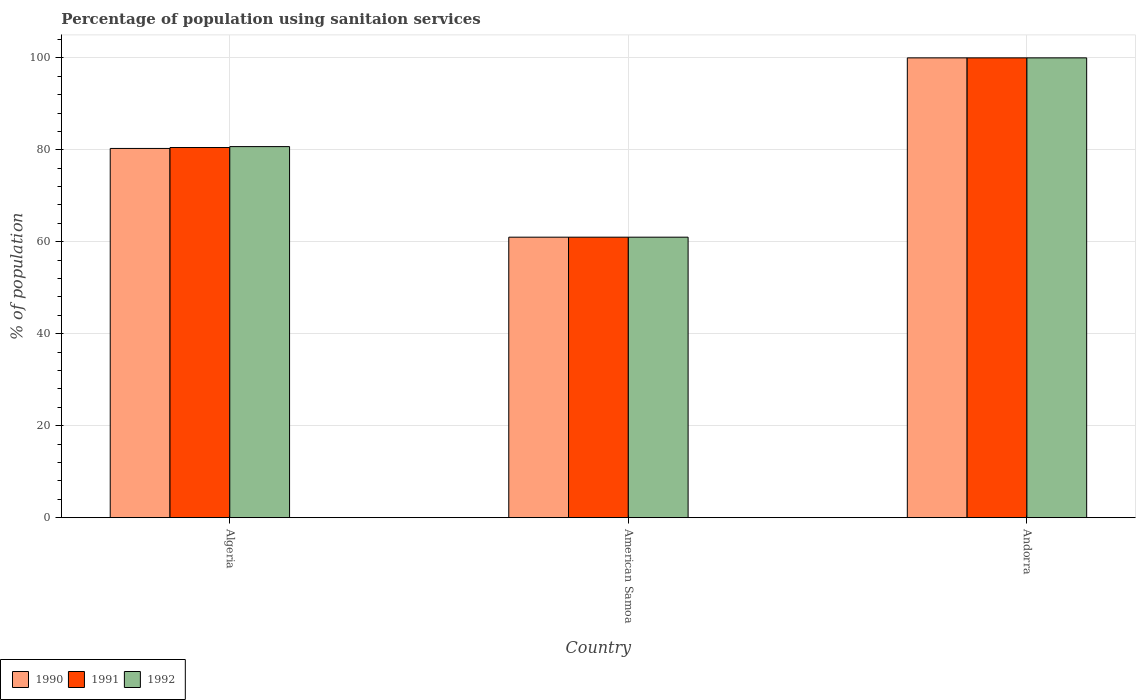How many different coloured bars are there?
Ensure brevity in your answer.  3. How many groups of bars are there?
Offer a terse response. 3. Are the number of bars per tick equal to the number of legend labels?
Offer a terse response. Yes. Are the number of bars on each tick of the X-axis equal?
Offer a terse response. Yes. What is the label of the 1st group of bars from the left?
Make the answer very short. Algeria. In how many cases, is the number of bars for a given country not equal to the number of legend labels?
Offer a very short reply. 0. What is the percentage of population using sanitaion services in 1991 in American Samoa?
Your answer should be very brief. 61. Across all countries, what is the maximum percentage of population using sanitaion services in 1991?
Offer a very short reply. 100. Across all countries, what is the minimum percentage of population using sanitaion services in 1991?
Your answer should be compact. 61. In which country was the percentage of population using sanitaion services in 1991 maximum?
Offer a terse response. Andorra. In which country was the percentage of population using sanitaion services in 1991 minimum?
Ensure brevity in your answer.  American Samoa. What is the total percentage of population using sanitaion services in 1990 in the graph?
Offer a terse response. 241.3. What is the difference between the percentage of population using sanitaion services in 1991 in American Samoa and that in Andorra?
Keep it short and to the point. -39. What is the difference between the percentage of population using sanitaion services in 1990 in American Samoa and the percentage of population using sanitaion services in 1991 in Andorra?
Give a very brief answer. -39. What is the average percentage of population using sanitaion services in 1991 per country?
Make the answer very short. 80.5. What is the ratio of the percentage of population using sanitaion services in 1991 in Algeria to that in Andorra?
Your answer should be compact. 0.81. What is the difference between the highest and the second highest percentage of population using sanitaion services in 1992?
Your answer should be compact. -19.3. Is the sum of the percentage of population using sanitaion services in 1991 in Algeria and American Samoa greater than the maximum percentage of population using sanitaion services in 1990 across all countries?
Give a very brief answer. Yes. Is it the case that in every country, the sum of the percentage of population using sanitaion services in 1990 and percentage of population using sanitaion services in 1992 is greater than the percentage of population using sanitaion services in 1991?
Your response must be concise. Yes. How many bars are there?
Provide a succinct answer. 9. How many countries are there in the graph?
Offer a terse response. 3. What is the difference between two consecutive major ticks on the Y-axis?
Give a very brief answer. 20. How are the legend labels stacked?
Keep it short and to the point. Horizontal. What is the title of the graph?
Make the answer very short. Percentage of population using sanitaion services. Does "1976" appear as one of the legend labels in the graph?
Keep it short and to the point. No. What is the label or title of the X-axis?
Ensure brevity in your answer.  Country. What is the label or title of the Y-axis?
Offer a very short reply. % of population. What is the % of population in 1990 in Algeria?
Your response must be concise. 80.3. What is the % of population of 1991 in Algeria?
Keep it short and to the point. 80.5. What is the % of population in 1992 in Algeria?
Your answer should be compact. 80.7. What is the % of population of 1991 in American Samoa?
Your answer should be very brief. 61. What is the % of population of 1991 in Andorra?
Give a very brief answer. 100. What is the % of population of 1992 in Andorra?
Your answer should be very brief. 100. Across all countries, what is the maximum % of population in 1992?
Offer a terse response. 100. Across all countries, what is the minimum % of population of 1991?
Provide a short and direct response. 61. Across all countries, what is the minimum % of population in 1992?
Your response must be concise. 61. What is the total % of population of 1990 in the graph?
Make the answer very short. 241.3. What is the total % of population of 1991 in the graph?
Offer a terse response. 241.5. What is the total % of population in 1992 in the graph?
Your answer should be compact. 241.7. What is the difference between the % of population of 1990 in Algeria and that in American Samoa?
Your answer should be compact. 19.3. What is the difference between the % of population of 1992 in Algeria and that in American Samoa?
Provide a short and direct response. 19.7. What is the difference between the % of population in 1990 in Algeria and that in Andorra?
Your answer should be compact. -19.7. What is the difference between the % of population in 1991 in Algeria and that in Andorra?
Ensure brevity in your answer.  -19.5. What is the difference between the % of population of 1992 in Algeria and that in Andorra?
Your answer should be compact. -19.3. What is the difference between the % of population of 1990 in American Samoa and that in Andorra?
Provide a succinct answer. -39. What is the difference between the % of population of 1991 in American Samoa and that in Andorra?
Keep it short and to the point. -39. What is the difference between the % of population in 1992 in American Samoa and that in Andorra?
Provide a succinct answer. -39. What is the difference between the % of population in 1990 in Algeria and the % of population in 1991 in American Samoa?
Offer a very short reply. 19.3. What is the difference between the % of population in 1990 in Algeria and the % of population in 1992 in American Samoa?
Your response must be concise. 19.3. What is the difference between the % of population of 1991 in Algeria and the % of population of 1992 in American Samoa?
Your answer should be compact. 19.5. What is the difference between the % of population in 1990 in Algeria and the % of population in 1991 in Andorra?
Your response must be concise. -19.7. What is the difference between the % of population of 1990 in Algeria and the % of population of 1992 in Andorra?
Make the answer very short. -19.7. What is the difference between the % of population of 1991 in Algeria and the % of population of 1992 in Andorra?
Your answer should be compact. -19.5. What is the difference between the % of population in 1990 in American Samoa and the % of population in 1991 in Andorra?
Keep it short and to the point. -39. What is the difference between the % of population in 1990 in American Samoa and the % of population in 1992 in Andorra?
Provide a short and direct response. -39. What is the difference between the % of population of 1991 in American Samoa and the % of population of 1992 in Andorra?
Make the answer very short. -39. What is the average % of population in 1990 per country?
Give a very brief answer. 80.43. What is the average % of population in 1991 per country?
Your answer should be very brief. 80.5. What is the average % of population of 1992 per country?
Provide a succinct answer. 80.57. What is the difference between the % of population of 1990 and % of population of 1992 in Algeria?
Keep it short and to the point. -0.4. What is the difference between the % of population in 1990 and % of population in 1991 in American Samoa?
Your answer should be very brief. 0. What is the difference between the % of population in 1990 and % of population in 1992 in American Samoa?
Ensure brevity in your answer.  0. What is the difference between the % of population in 1990 and % of population in 1992 in Andorra?
Your response must be concise. 0. What is the ratio of the % of population of 1990 in Algeria to that in American Samoa?
Provide a short and direct response. 1.32. What is the ratio of the % of population in 1991 in Algeria to that in American Samoa?
Your answer should be compact. 1.32. What is the ratio of the % of population in 1992 in Algeria to that in American Samoa?
Your answer should be very brief. 1.32. What is the ratio of the % of population in 1990 in Algeria to that in Andorra?
Offer a very short reply. 0.8. What is the ratio of the % of population of 1991 in Algeria to that in Andorra?
Your response must be concise. 0.81. What is the ratio of the % of population in 1992 in Algeria to that in Andorra?
Offer a terse response. 0.81. What is the ratio of the % of population of 1990 in American Samoa to that in Andorra?
Provide a short and direct response. 0.61. What is the ratio of the % of population of 1991 in American Samoa to that in Andorra?
Ensure brevity in your answer.  0.61. What is the ratio of the % of population of 1992 in American Samoa to that in Andorra?
Keep it short and to the point. 0.61. What is the difference between the highest and the second highest % of population in 1991?
Your answer should be very brief. 19.5. What is the difference between the highest and the second highest % of population of 1992?
Your response must be concise. 19.3. What is the difference between the highest and the lowest % of population of 1992?
Ensure brevity in your answer.  39. 